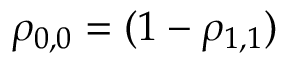<formula> <loc_0><loc_0><loc_500><loc_500>\rho _ { 0 , 0 } = ( 1 - \rho _ { 1 , 1 } )</formula> 